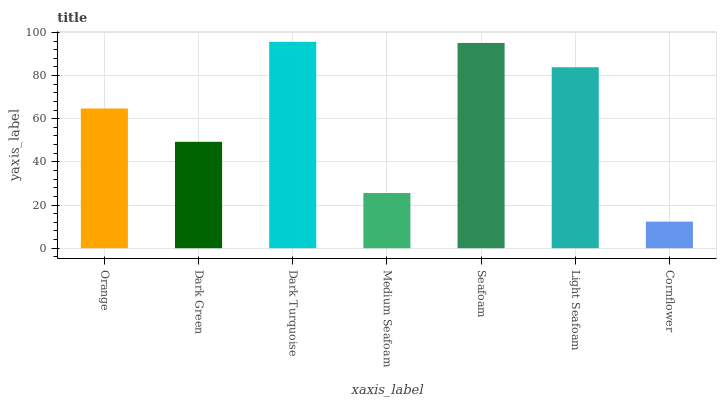Is Cornflower the minimum?
Answer yes or no. Yes. Is Dark Turquoise the maximum?
Answer yes or no. Yes. Is Dark Green the minimum?
Answer yes or no. No. Is Dark Green the maximum?
Answer yes or no. No. Is Orange greater than Dark Green?
Answer yes or no. Yes. Is Dark Green less than Orange?
Answer yes or no. Yes. Is Dark Green greater than Orange?
Answer yes or no. No. Is Orange less than Dark Green?
Answer yes or no. No. Is Orange the high median?
Answer yes or no. Yes. Is Orange the low median?
Answer yes or no. Yes. Is Seafoam the high median?
Answer yes or no. No. Is Medium Seafoam the low median?
Answer yes or no. No. 